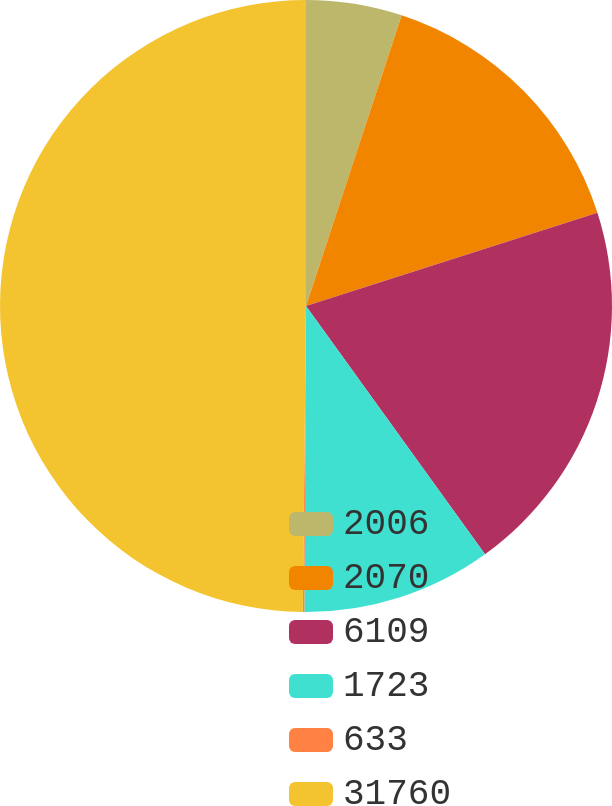Convert chart. <chart><loc_0><loc_0><loc_500><loc_500><pie_chart><fcel>2006<fcel>2070<fcel>6109<fcel>1723<fcel>633<fcel>31760<nl><fcel>5.06%<fcel>15.01%<fcel>19.98%<fcel>10.03%<fcel>0.08%<fcel>49.83%<nl></chart> 